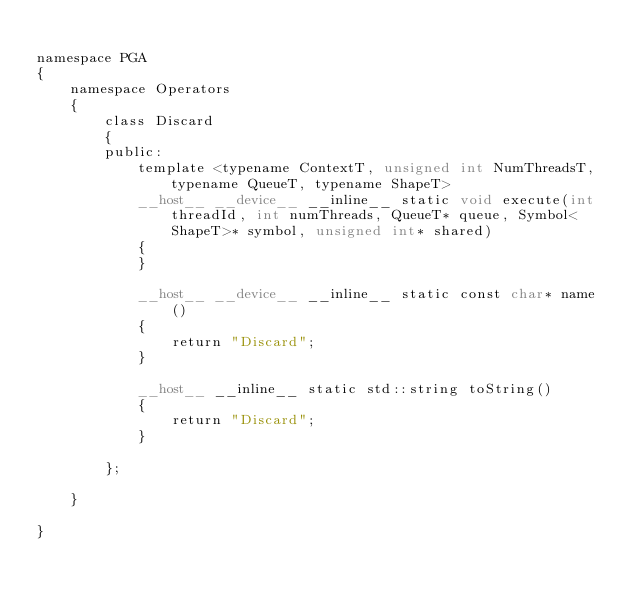Convert code to text. <code><loc_0><loc_0><loc_500><loc_500><_Cuda_>
namespace PGA
{
	namespace Operators
	{
		class Discard
		{
		public:
			template <typename ContextT, unsigned int NumThreadsT, typename QueueT, typename ShapeT>
			__host__ __device__ __inline__ static void execute(int threadId, int numThreads, QueueT* queue, Symbol<ShapeT>* symbol, unsigned int* shared)
			{
			}

			__host__ __device__ __inline__ static const char* name()
			{
				return "Discard";
			}

			__host__ __inline__ static std::string toString()
			{
				return "Discard";
			}

		};

	}

}
</code> 